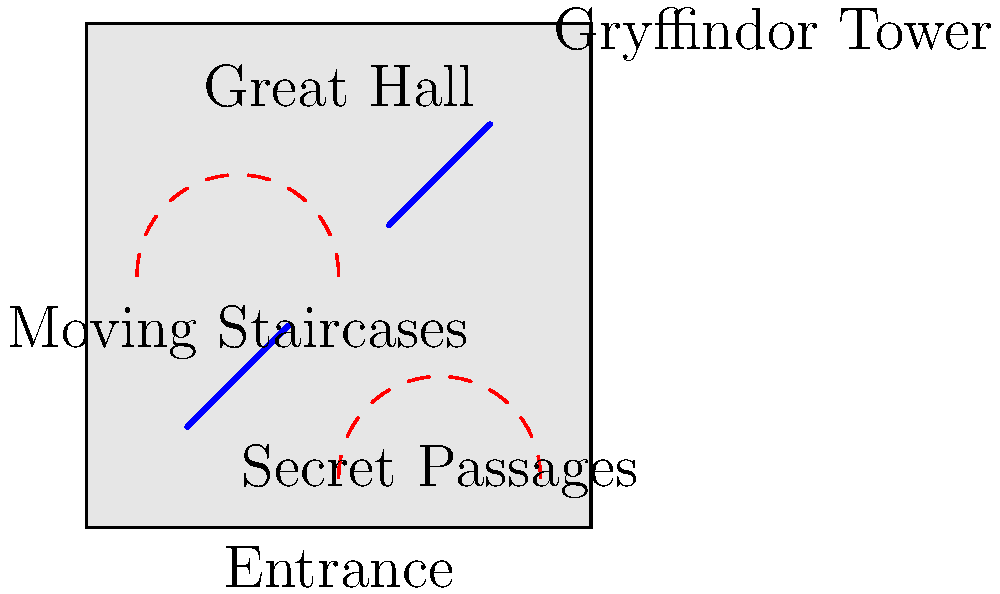In the architectural layout of Hogwarts Castle, which feature connects different floors and changes its configuration, potentially causing students to arrive at unexpected locations? To answer this question, let's break down the key architectural features of Hogwarts Castle:

1. The castle is known for its complex and magical layout, with many unique features that make navigation challenging.

2. One of the most distinctive elements is the moving staircases. These staircases:
   a) Connect different floors of the castle
   b) Change their position and configuration regularly
   c) Can lead students to different locations than intended

3. Other notable features include:
   a) Secret passages, which provide shortcuts but are not visible to all
   b) Specific locations like the Great Hall and House towers
   c) Enchanted rooms that can change or appear/disappear

4. While secret passages are hidden and stationary, the moving staircases are a visible and dynamic feature that actively alters the castle's internal layout.

5. The moving staircases are known to:
   a) Shift on certain days of the week
   b) Lead to different corridors or floors unexpectedly
   c) Sometimes move while students are on them

6. This feature often causes confusion and can make students late for classes or end up in unfamiliar parts of the castle.

Given these points, the architectural feature that connects different floors and changes its configuration, potentially causing students to arrive at unexpected locations, is clearly the moving staircases.
Answer: Moving staircases 